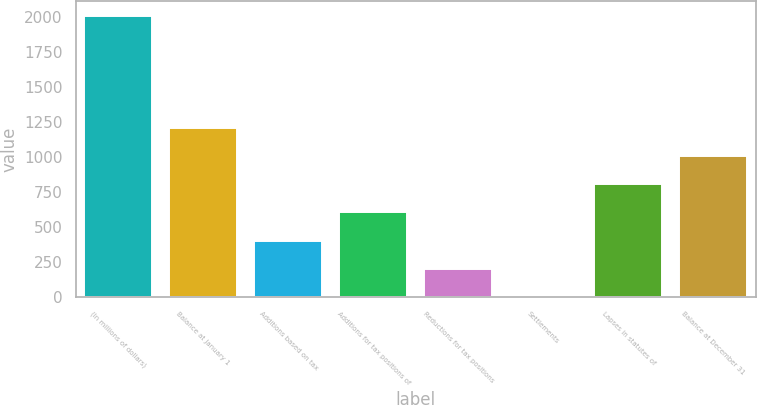<chart> <loc_0><loc_0><loc_500><loc_500><bar_chart><fcel>(In millions of dollars)<fcel>Balance at January 1<fcel>Additions based on tax<fcel>Additions for tax positions of<fcel>Reductions for tax positions<fcel>Settlements<fcel>Lapses in statutes of<fcel>Balance at December 31<nl><fcel>2010<fcel>1207.6<fcel>405.2<fcel>605.8<fcel>204.6<fcel>4<fcel>806.4<fcel>1007<nl></chart> 